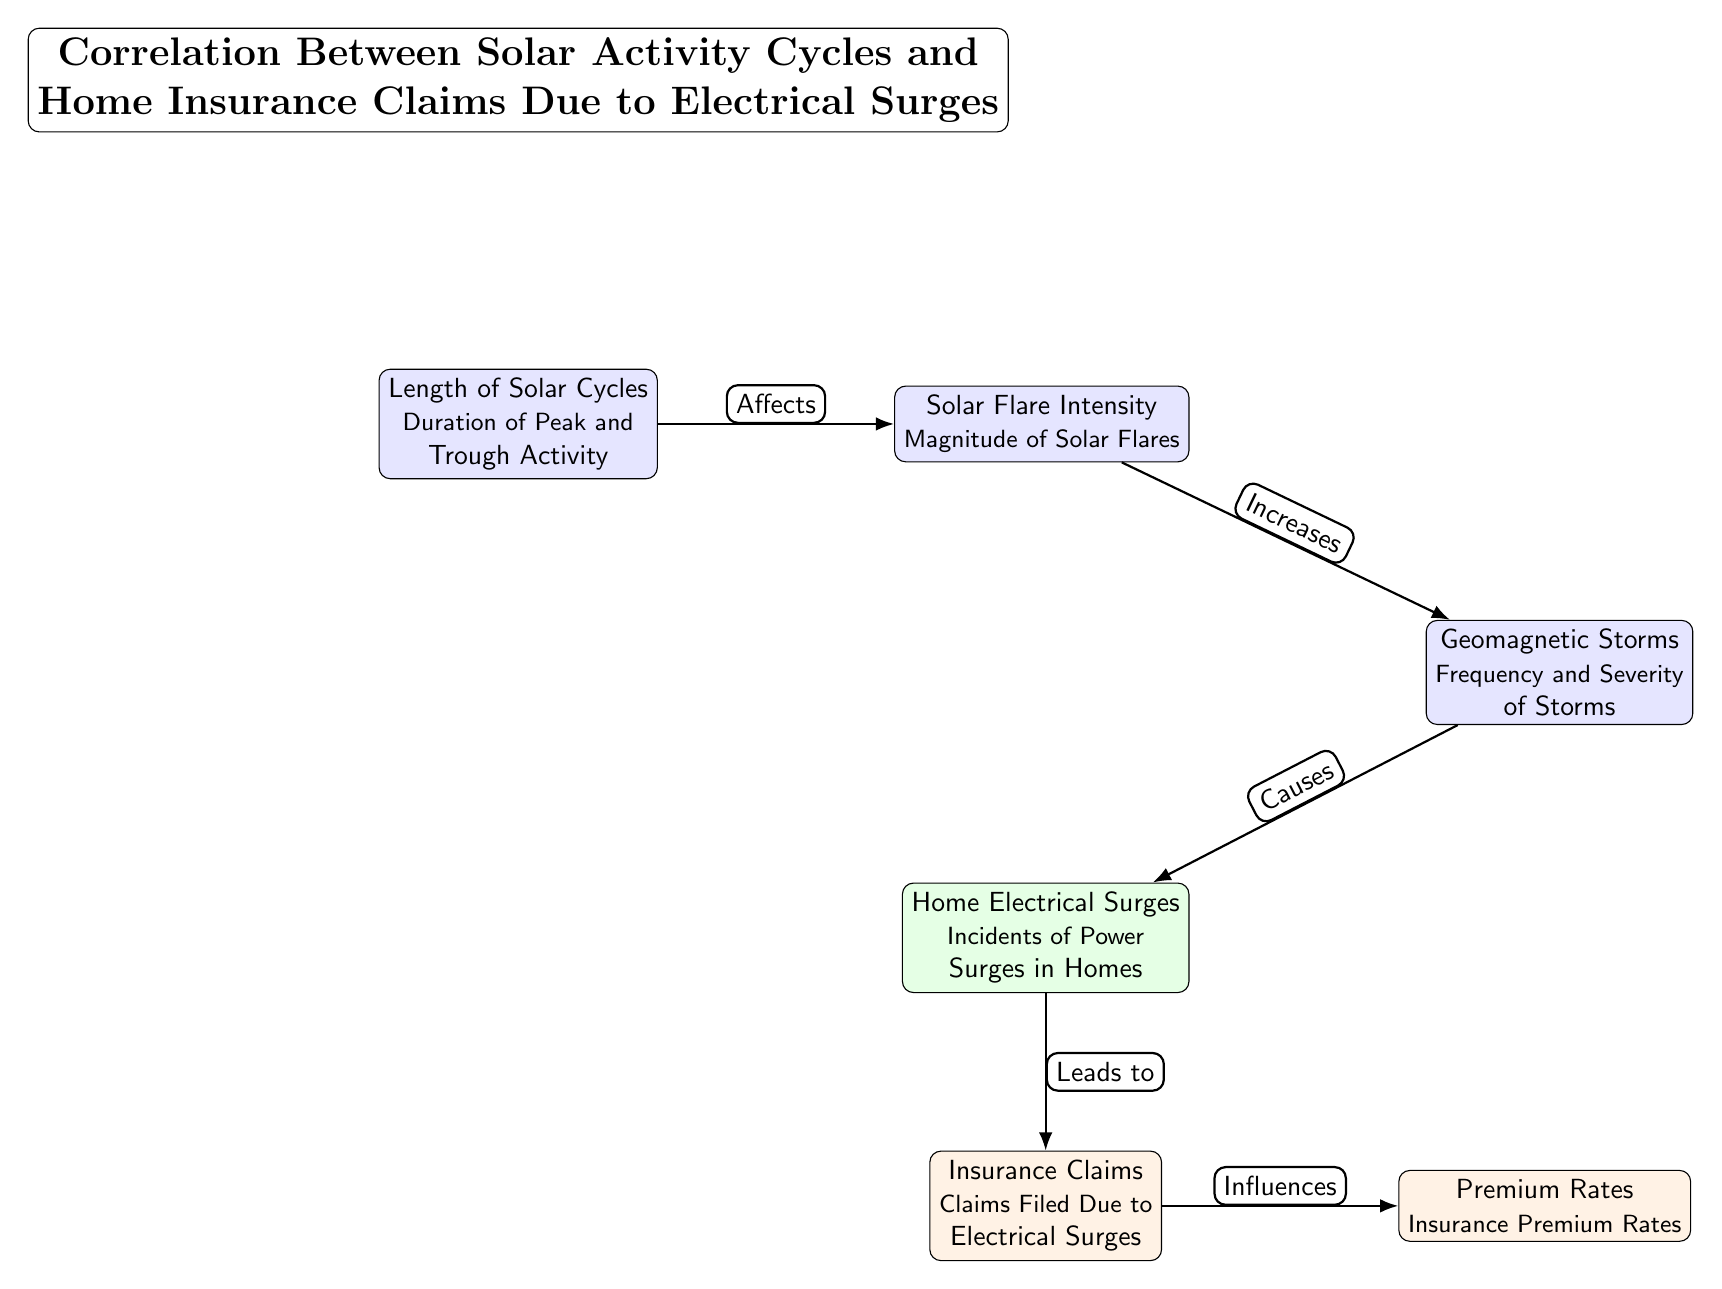What is the effect of solar cycles on solar flares? The diagram indicates that solar cycles "Affects" solar flares, meaning there is a direct correlation between the length of solar cycles and the intensity of solar flares.
Answer: Affects How many nodes are present in the diagram? The diagram contains six nodes: Length of Solar Cycles, Solar Flare Intensity, Geomagnetic Storms, Home Electrical Surges, Insurance Claims, and Premium Rates.
Answer: Six What leads to an increase in insurance claims? The diagram showcases that Home Electrical Surges "Leads to" Claims, indicating that incidents of power surges cause an increase in insurance claims.
Answer: Leads to What aspect of solar activity correlates with geomagnetic storms? The diagram illustrates that Solar Flare Intensity "Increases" the frequency and severity of geomagnetic storms, creating a direct link between these two factors.
Answer: Increases What influences premium rates according to the diagram? According to the diagram, Insurance Claims "Influences" Premium Rates, meaning that the number of claims filed due to electrical surges has an impact on the rates of insurance premiums.
Answer: Influences What type of activity does the first node describe? The first node describes solar cycles, specifically their length and the duration of peak and trough activity, indicating it is about solar activity cycles.
Answer: Solar activity cycles How do electrical surges relate to geomagnetic storms? The diagram states that Geomagnetic Storms "Causes" electrical surges, implying that these storms lead to incidents of power surges in homes.
Answer: Causes What is the nature of the relationship between electrical surges and premium rates? The relationship is that electrical surges lead to claims, which in turn influence premium rates, forming a flow from electrical incidents to financial implications.
Answer: Flow of claims to premium rates How is solar flare intensity described in the diagram? Solar flare intensity is described as the magnitude of solar flares, indicating the strength of these phenomena associated with solar activity.
Answer: Magnitude of Solar Flares 